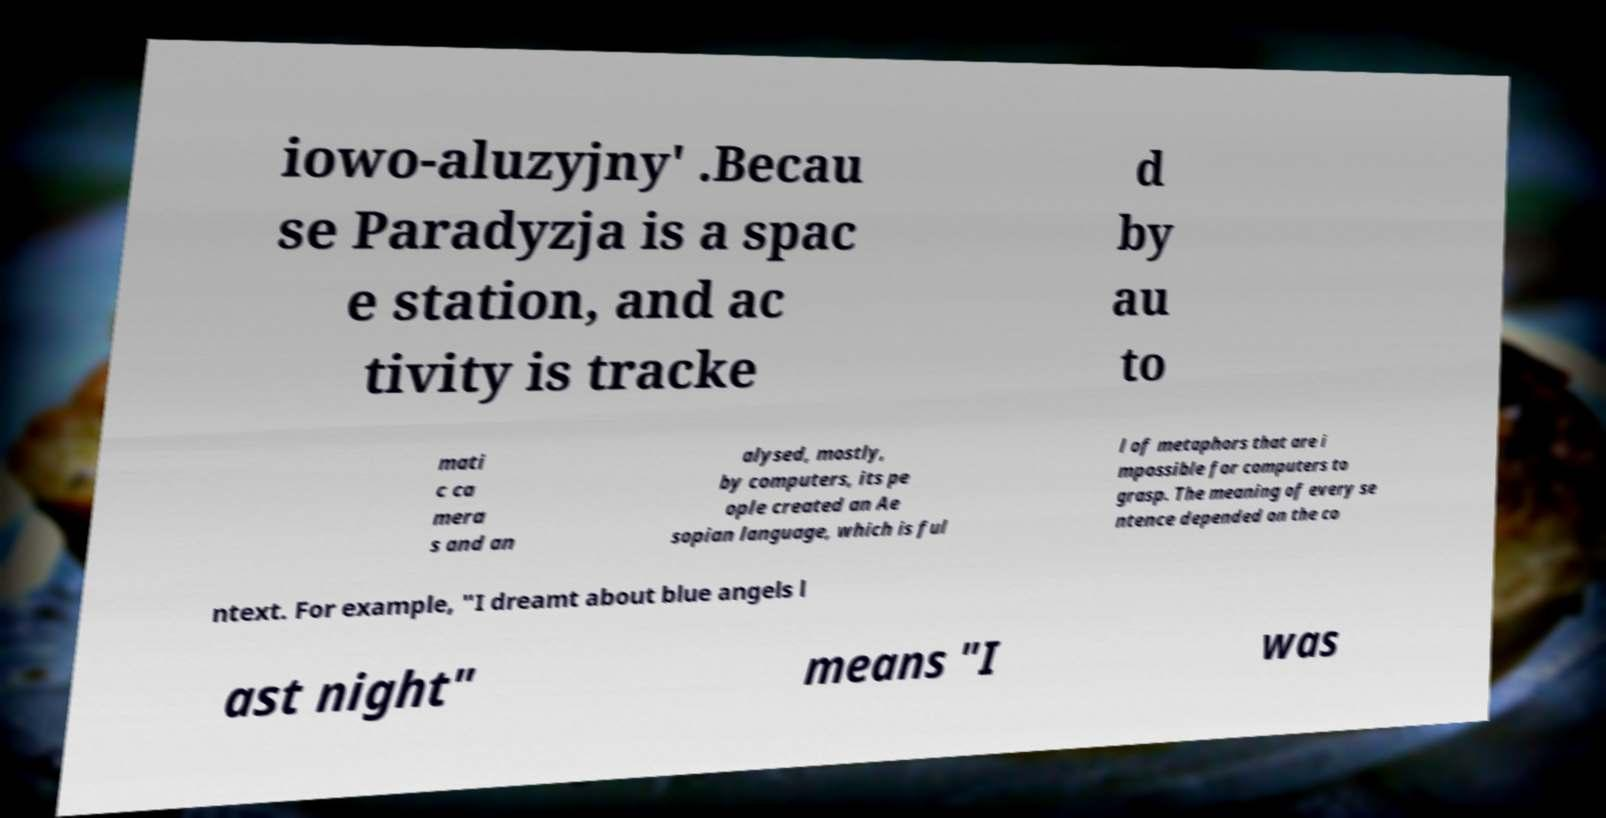Please identify and transcribe the text found in this image. iowo-aluzyjny' .Becau se Paradyzja is a spac e station, and ac tivity is tracke d by au to mati c ca mera s and an alysed, mostly, by computers, its pe ople created an Ae sopian language, which is ful l of metaphors that are i mpossible for computers to grasp. The meaning of every se ntence depended on the co ntext. For example, "I dreamt about blue angels l ast night" means "I was 